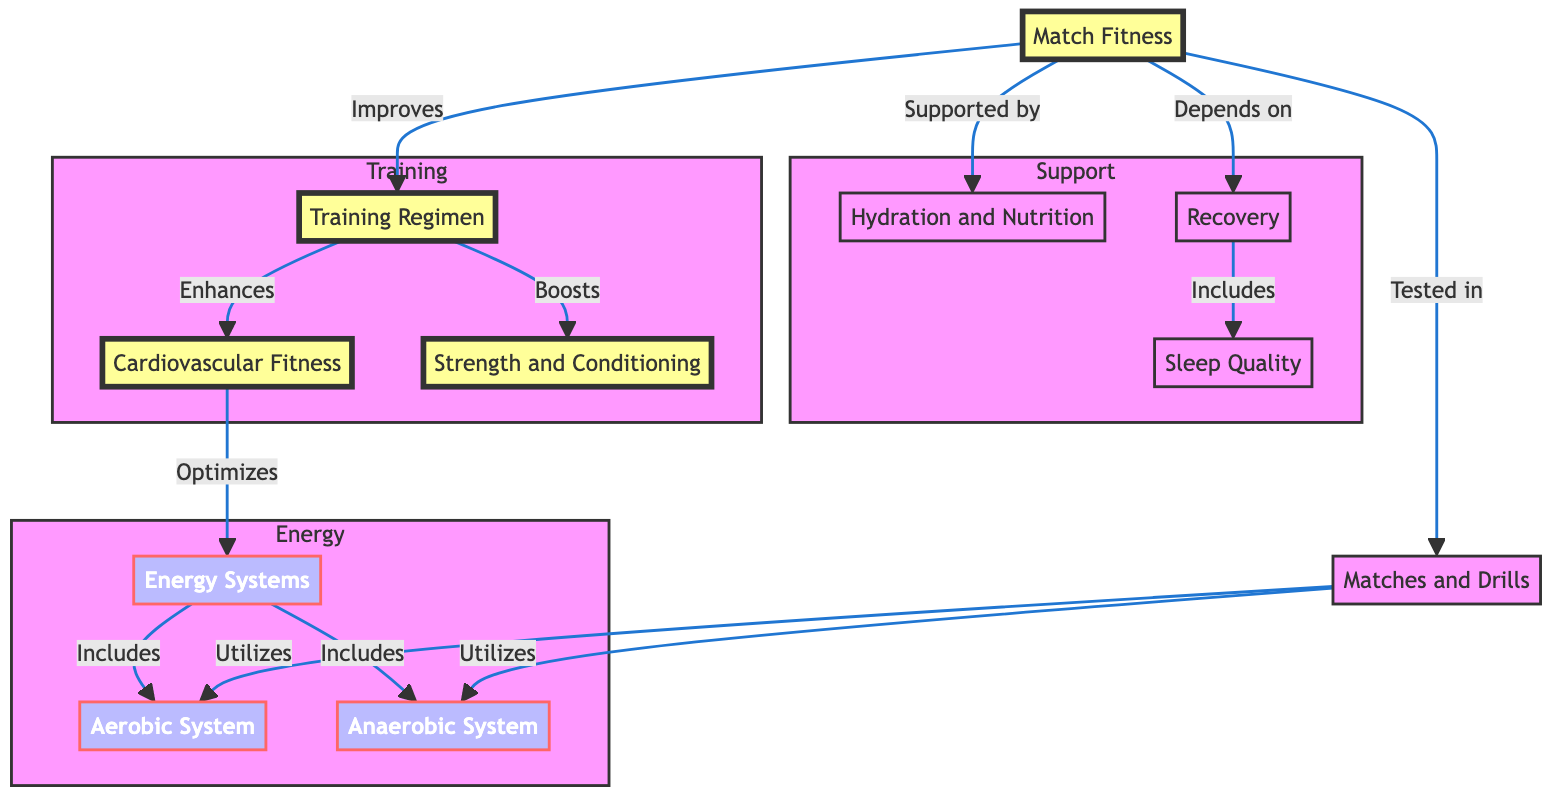What is the central node in the diagram? The central node represents the primary focus of the diagram, which is "Match Fitness." It connects to various other nodes indicating its importance in training, energy, and support.
Answer: Match Fitness How many training aspects are represented in the diagram? There are three specific training aspects depicted: "Training Regimen," "Cardiovascular Fitness," and "Strength and Conditioning." These are grouped under the "Training" subgraph.
Answer: 3 What does "Match Fitness" depend on for proper recovery? The diagram indicates that "Match Fitness" depends on "Recovery," which is part of the support structure, highlighting the significance of recovery in maintaining fitness.
Answer: Recovery Which two energy systems are included in the diagram? The diagram outlines two distinct energy systems: "Aerobic System" and "Anaerobic System." Both are subcomponents of the main "Energy Systems" node.
Answer: Aerobic System, Anaerobic System How does "Training Regimen" enhance "Cardiovascular Fitness"? "Training Regimen" serves as a direct input to "Cardiovascular Fitness," suggesting that a well-structured training program directly enhances cardiovascular capabilities, which are crucial for match fitness.
Answer: Enhances What are the elements that support "Match Fitness"? The supporting elements for "Match Fitness" are "Hydration and Nutrition," "Recovery," and "Sleep Quality," all of which contribute to overall fitness and performance.
Answer: Hydration and Nutrition, Recovery, Sleep Quality Which node utilizes both energy systems? The "Matches and Drills" node directly utilizes both the "Aerobic System" and "Anaerobic System," indicating that these systems are crucial during actual play and practice drills.
Answer: Matches and Drills What improves "Match Fitness"? The diagram shows that "Match Fitness" is improved by the "Training Regimen," which encompasses various training components and practices that enhance overall fitness.
Answer: Training Regimen How many nodes are there in the "Support" subgraph? The "Support" subgraph consists of three nodes: "Hydration and Nutrition," "Recovery," and "Sleep Quality," each playing a vital role in supporting a player's match fitness.
Answer: 3 